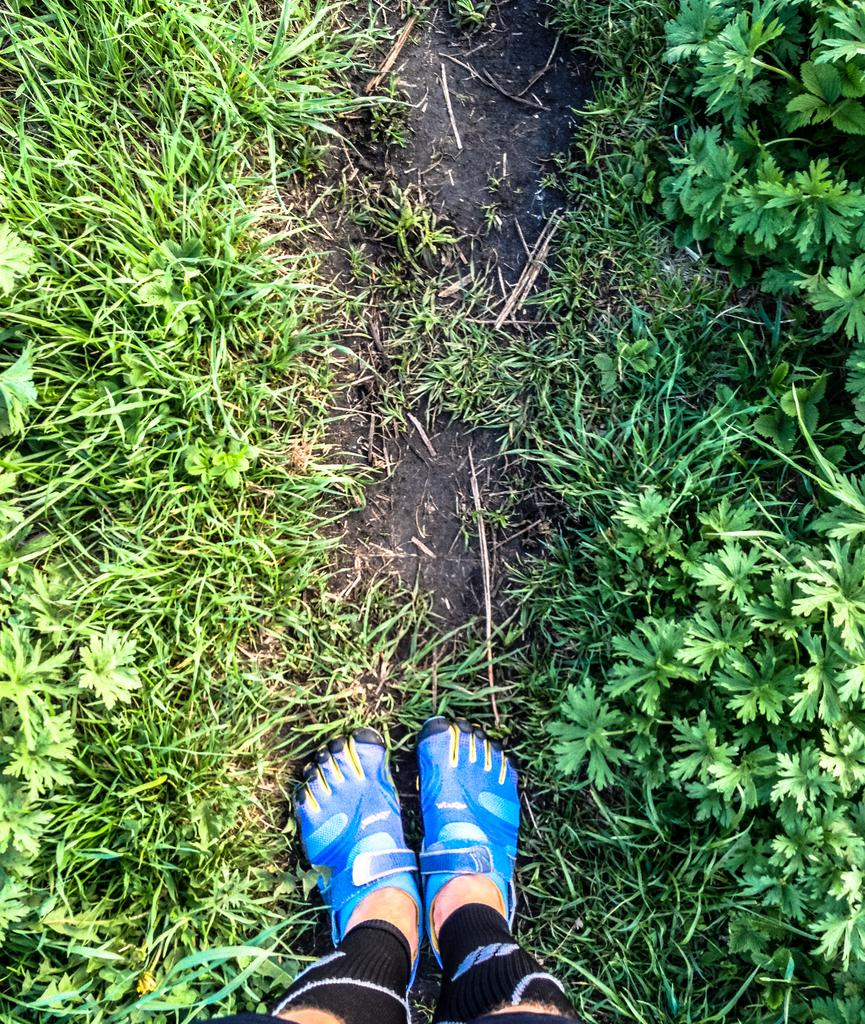What type of vegetation is present in the image? There is grass in the image. Can you describe the distribution of the grass in the image? The grass is present all over the place in the image. What part of a person or animal can be seen at the bottom of the image? Two legs are visible at the bottom of the image. Who is the creator of the crowd in the image? There is no crowd present in the image, and therefore no creator can be identified. 